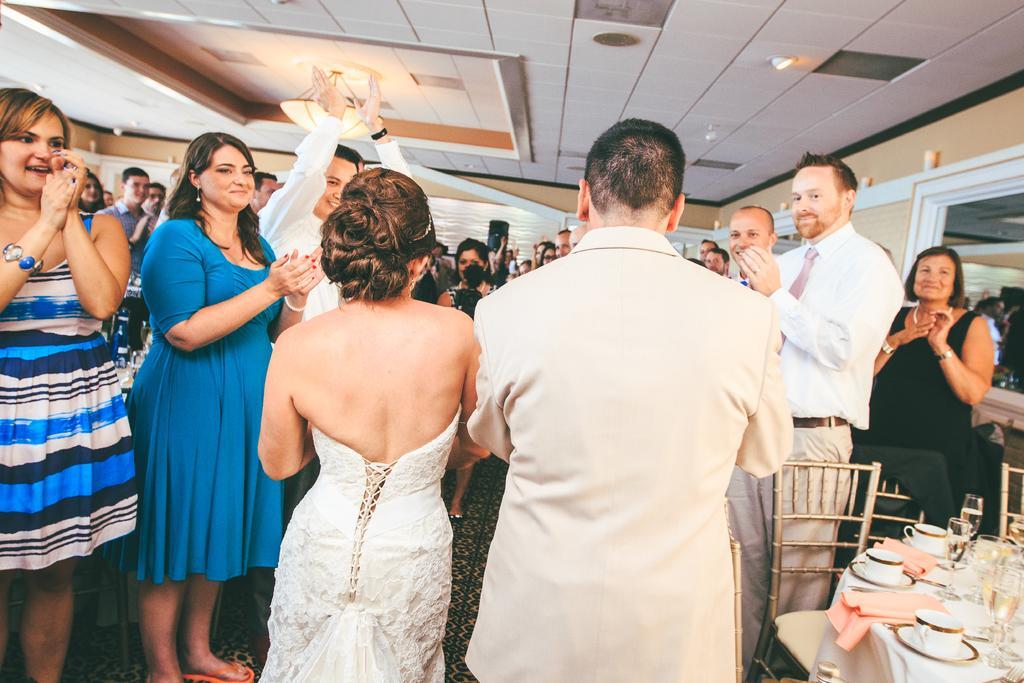How would you summarize this image in a sentence or two? In this image in center there are two persons who are standing, on the right side and left side there are few people who are standing and clapping. On the bottom of the right corner there is one table and some chairs, on the table there are some cups, saucers kerchiefs and some glasses. In the background there is a wall and some boards, on the right side there is a wall and mirror. On the top there is ceiling and some lights. 